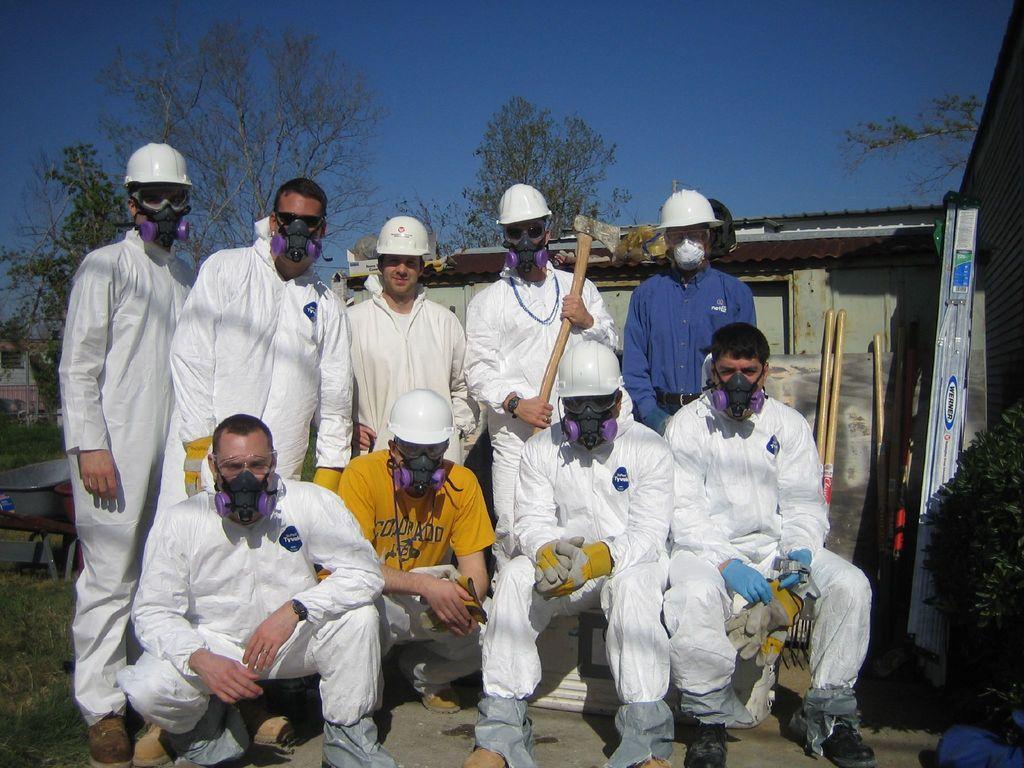Could you give a brief overview of what you see in this image? In this image we can see a group of people wearing helmets and mask. In that a person is holding an axe and the other is holding the gloves. We can also see a house with a roof, a board, some wooden sticks, plants, grass, some objects placed on the table, some trees and the sky which looks cloudy. 